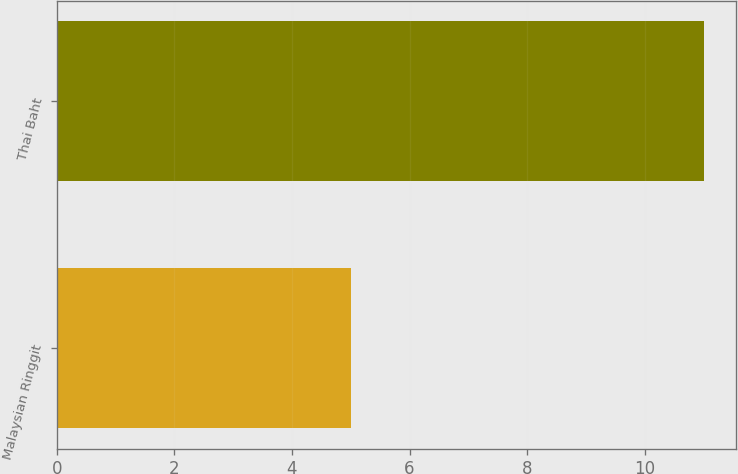Convert chart. <chart><loc_0><loc_0><loc_500><loc_500><bar_chart><fcel>Malaysian Ringgit<fcel>Thai Baht<nl><fcel>5<fcel>11<nl></chart> 